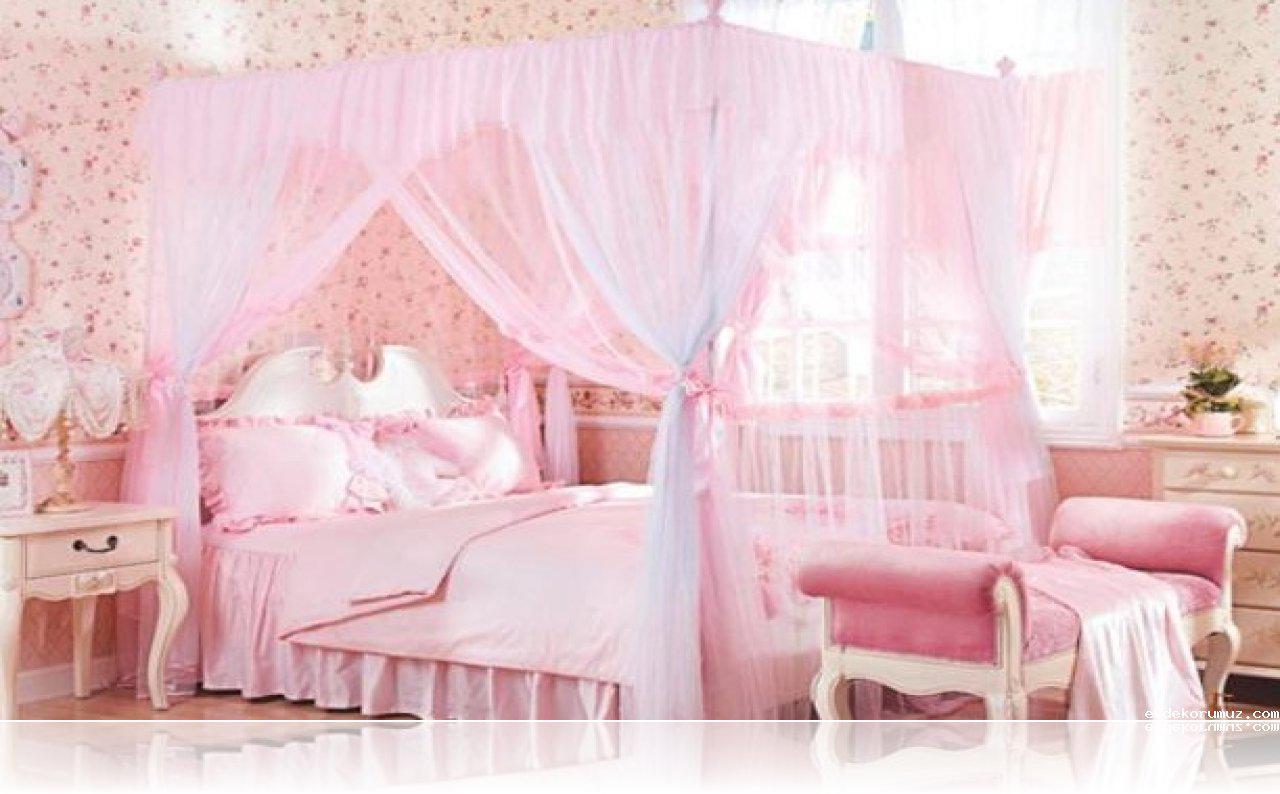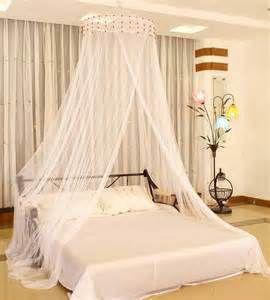The first image is the image on the left, the second image is the image on the right. For the images displayed, is the sentence "At least one image shows a gauzy canopy that drapes a bed from a round shape suspended from the ceiling, and at least one image features a pink canopy draping a bed." factually correct? Answer yes or no. Yes. The first image is the image on the left, the second image is the image on the right. Examine the images to the left and right. Is the description "At least one bed net is pink." accurate? Answer yes or no. Yes. 